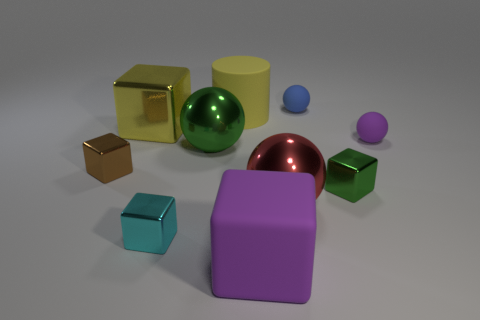There is a purple ball that is the same size as the cyan object; what is it made of?
Make the answer very short. Rubber. Does the large cube that is behind the tiny green thing have the same color as the small rubber ball that is behind the big yellow cylinder?
Offer a terse response. No. Are there any tiny purple metal objects of the same shape as the small brown metallic thing?
Offer a terse response. No. What is the shape of the blue thing that is the same size as the green metal block?
Give a very brief answer. Sphere. What number of big cubes have the same color as the rubber cylinder?
Your answer should be compact. 1. What size is the yellow thing that is right of the yellow shiny cube?
Your answer should be very brief. Large. How many objects have the same size as the cylinder?
Keep it short and to the point. 4. There is a block that is made of the same material as the tiny blue object; what is its color?
Keep it short and to the point. Purple. Are there fewer tiny matte balls in front of the cyan metal thing than large purple cubes?
Provide a short and direct response. Yes. There is a large yellow object that is the same material as the blue ball; what shape is it?
Your answer should be very brief. Cylinder. 